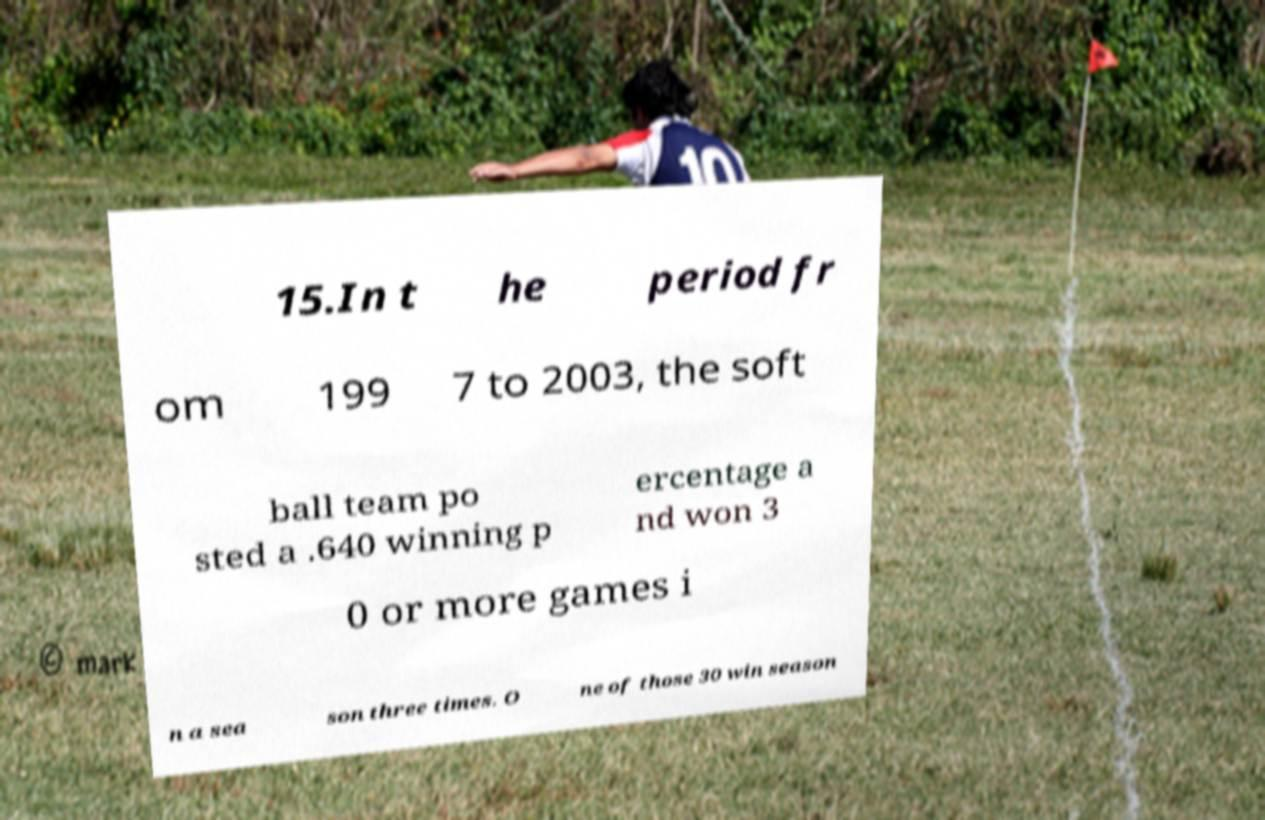Can you read and provide the text displayed in the image?This photo seems to have some interesting text. Can you extract and type it out for me? 15.In t he period fr om 199 7 to 2003, the soft ball team po sted a .640 winning p ercentage a nd won 3 0 or more games i n a sea son three times. O ne of those 30 win season 